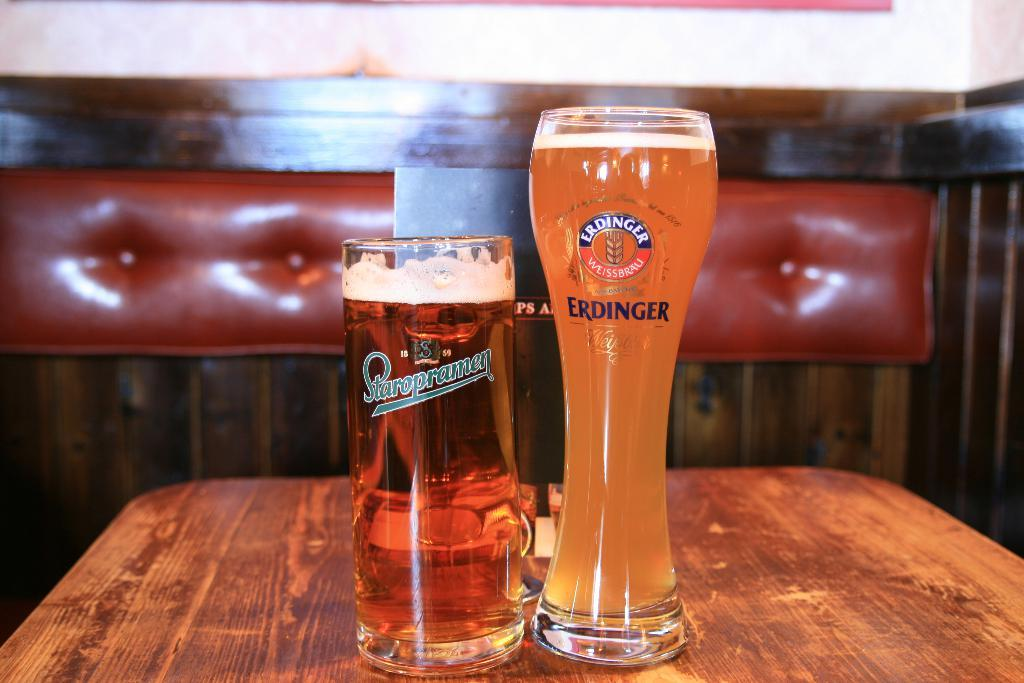<image>
Present a compact description of the photo's key features. 2 beers in different sized containers by Staropramen and Erdinger. 